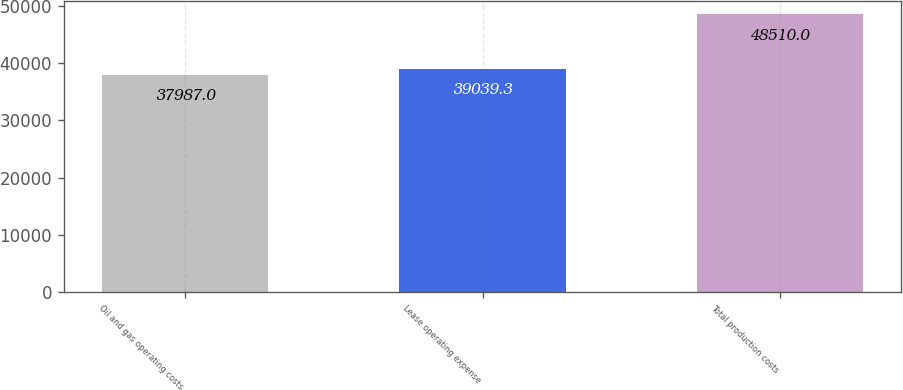<chart> <loc_0><loc_0><loc_500><loc_500><bar_chart><fcel>Oil and gas operating costs<fcel>Lease operating expense<fcel>Total production costs<nl><fcel>37987<fcel>39039.3<fcel>48510<nl></chart> 